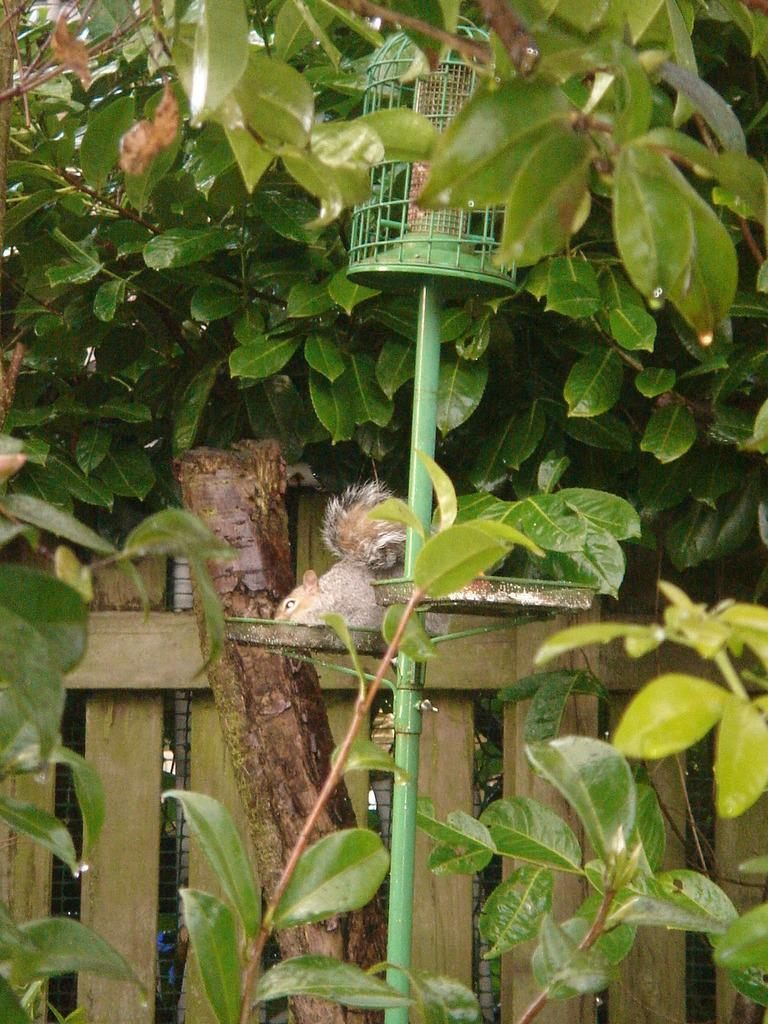What type of animal is in the image? The type of animal cannot be determined from the provided facts. What is attached to the pole in the image? There is a cage attached to the pole in the image. What kind of barrier is present in the image? There is a wooden fence in the image. What type of vegetation is in the image? There are a few plants in the image. What type of whip is being used to select the animal in the image? There is no whip or selection process depicted in the image. 